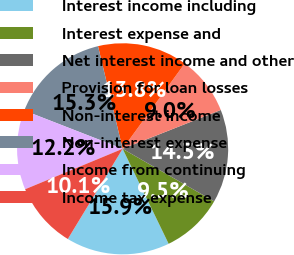Convert chart to OTSL. <chart><loc_0><loc_0><loc_500><loc_500><pie_chart><fcel>Interest income including<fcel>Interest expense and<fcel>Net interest income and other<fcel>Provision for loan losses<fcel>Non-interest income<fcel>Non-interest expense<fcel>Income from continuing<fcel>Income tax expense<nl><fcel>15.87%<fcel>9.52%<fcel>14.29%<fcel>8.99%<fcel>13.76%<fcel>15.34%<fcel>12.17%<fcel>10.05%<nl></chart> 